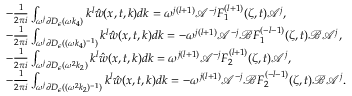<formula> <loc_0><loc_0><loc_500><loc_500>\begin{array} { r l } & { - \frac { 1 } { 2 \pi i } \int _ { \omega ^ { j } \partial D _ { \epsilon } ( \omega k _ { 4 } ) } k ^ { l } \hat { w } ( x , t , k ) d k = \omega ^ { j ( l + 1 ) } \mathcal { A } ^ { - j } F _ { 1 } ^ { ( l + 1 ) } ( \zeta , t ) \mathcal { A } ^ { j } , } \\ & { - \frac { 1 } { 2 \pi i } \int _ { \omega ^ { j } \partial D _ { \epsilon } ( ( \omega k _ { 4 } ) ^ { - 1 } ) } k ^ { l } \hat { w } ( x , t , k ) d k = - \omega ^ { j ( l + 1 ) } \mathcal { A } ^ { - j } \mathcal { B } F _ { 1 } ^ { ( - l - 1 ) } ( \zeta , t ) \mathcal { B } \mathcal { A } ^ { j } , } \\ & { - \frac { 1 } { 2 \pi i } \int _ { \omega ^ { j } \partial D _ { \epsilon } ( \omega ^ { 2 } k _ { 2 } ) } k ^ { l } \hat { w } ( x , t , k ) d k = \omega ^ { j ( l + 1 ) } \mathcal { A } ^ { - j } F _ { 2 } ^ { ( l + 1 ) } ( \zeta , t ) \mathcal { A } ^ { j } , } \\ & { - \frac { 1 } { 2 \pi i } \int _ { \omega ^ { j } \partial D _ { \epsilon } ( ( \omega ^ { 2 } k _ { 2 } ) ^ { - 1 } ) } k ^ { l } \hat { w } ( x , t , k ) d k = - \omega ^ { j ( l + 1 ) } \mathcal { A } ^ { - j } \mathcal { B } F _ { 2 } ^ { ( - l - 1 ) } ( \zeta , t ) \mathcal { B } \mathcal { A } ^ { j } . } \end{array}</formula> 